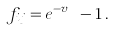Convert formula to latex. <formula><loc_0><loc_0><loc_500><loc_500>f _ { i j } = e ^ { - v _ { i j } } - 1 \, .</formula> 